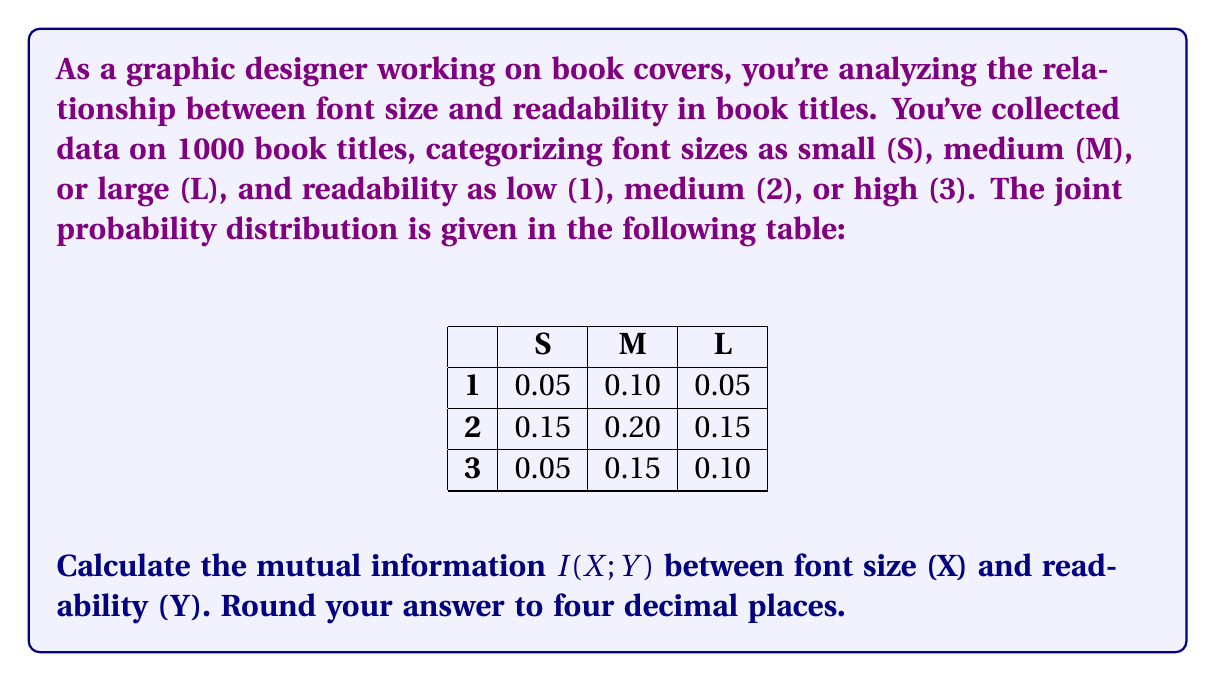What is the answer to this math problem? To calculate the mutual information $I(X;Y)$, we'll follow these steps:

1) First, calculate the marginal probabilities:

   $P(X=S) = 0.05 + 0.15 + 0.05 = 0.25$
   $P(X=M) = 0.10 + 0.20 + 0.15 = 0.45$
   $P(X=L) = 0.05 + 0.15 + 0.10 = 0.30$

   $P(Y=1) = 0.05 + 0.10 + 0.05 = 0.20$
   $P(Y=2) = 0.15 + 0.20 + 0.15 = 0.50$
   $P(Y=3) = 0.05 + 0.15 + 0.10 = 0.30$

2) The mutual information is defined as:

   $$I(X;Y) = \sum_{x \in X} \sum_{y \in Y} P(x,y) \log_2 \frac{P(x,y)}{P(x)P(y)}$$

3) Let's calculate each term:

   $0.05 \log_2 \frac{0.05}{0.25 \cdot 0.20} = 0.05 \log_2 1 = 0$
   $0.10 \log_2 \frac{0.10}{0.45 \cdot 0.20} \approx 0.0280$
   $0.05 \log_2 \frac{0.05}{0.30 \cdot 0.20} \approx 0.0219$
   $0.15 \log_2 \frac{0.15}{0.25 \cdot 0.50} \approx 0.0317$
   $0.20 \log_2 \frac{0.20}{0.45 \cdot 0.50} \approx 0.0170$
   $0.15 \log_2 \frac{0.15}{0.30 \cdot 0.50} \approx 0.0219$
   $0.05 \log_2 \frac{0.05}{0.25 \cdot 0.30} \approx 0.0073$
   $0.15 \log_2 \frac{0.15}{0.45 \cdot 0.30} \approx 0.0219$
   $0.10 \log_2 \frac{0.10}{0.30 \cdot 0.30} \approx 0.0110$

4) Sum all these terms:

   $I(X;Y) \approx 0 + 0.0280 + 0.0219 + 0.0317 + 0.0170 + 0.0219 + 0.0073 + 0.0219 + 0.0110 = 0.1607$

5) Rounding to four decimal places:

   $I(X;Y) \approx 0.1607$ bits
Answer: 0.1607 bits 